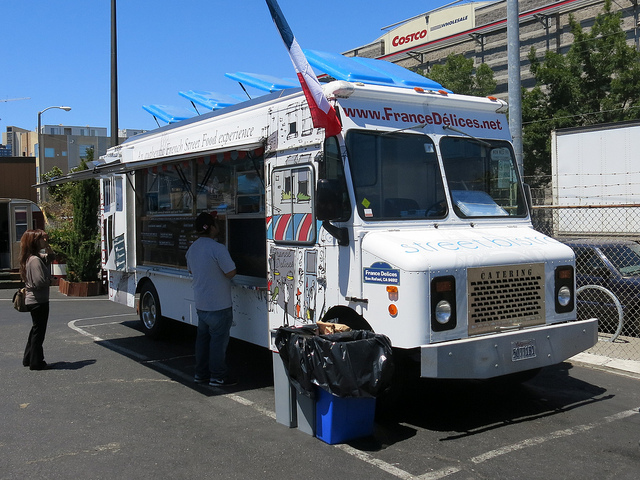Identify and read out the text in this image. Costco www.FranceDelices.net street Feed 